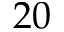Convert formula to latex. <formula><loc_0><loc_0><loc_500><loc_500>2 0</formula> 